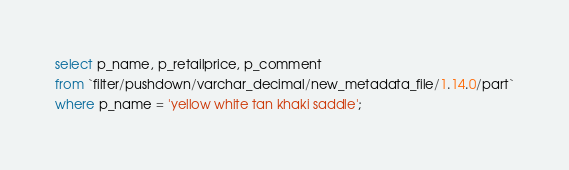Convert code to text. <code><loc_0><loc_0><loc_500><loc_500><_SQL_>select p_name, p_retailprice, p_comment
from `filter/pushdown/varchar_decimal/new_metadata_file/1.14.0/part`
where p_name = 'yellow white tan khaki saddle';</code> 